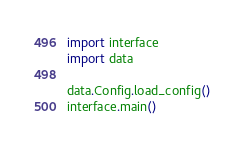<code> <loc_0><loc_0><loc_500><loc_500><_Python_>
import interface
import data

data.Config.load_config()
interface.main()
</code> 